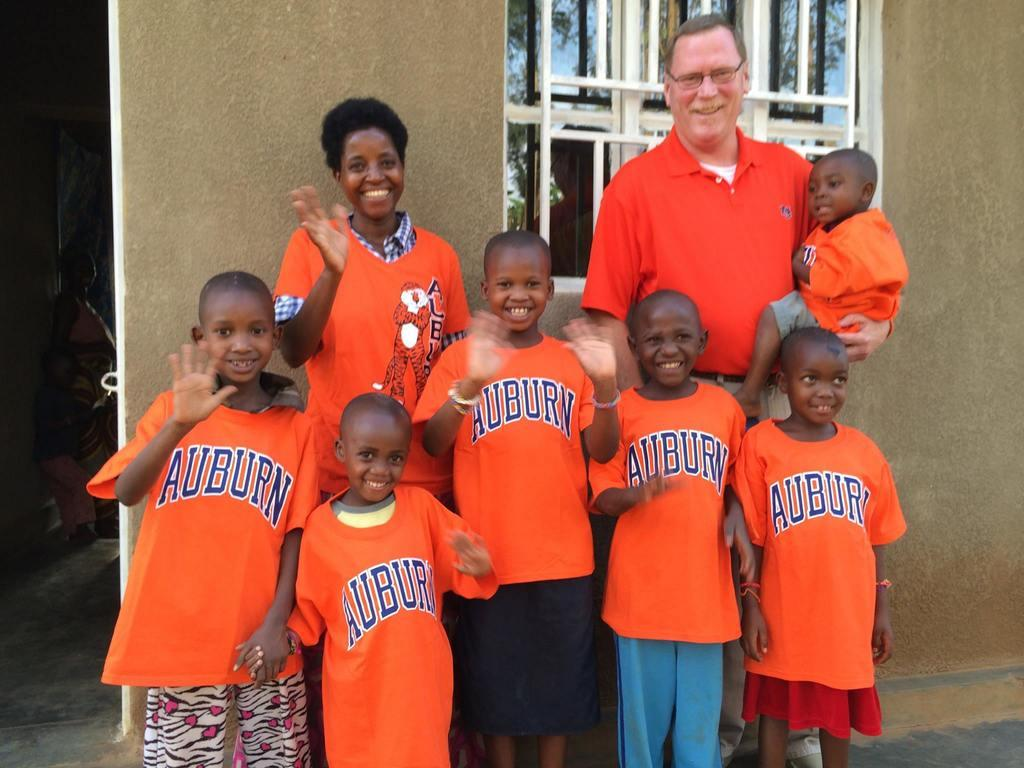<image>
Summarize the visual content of the image. some people with the words auburn on the back 